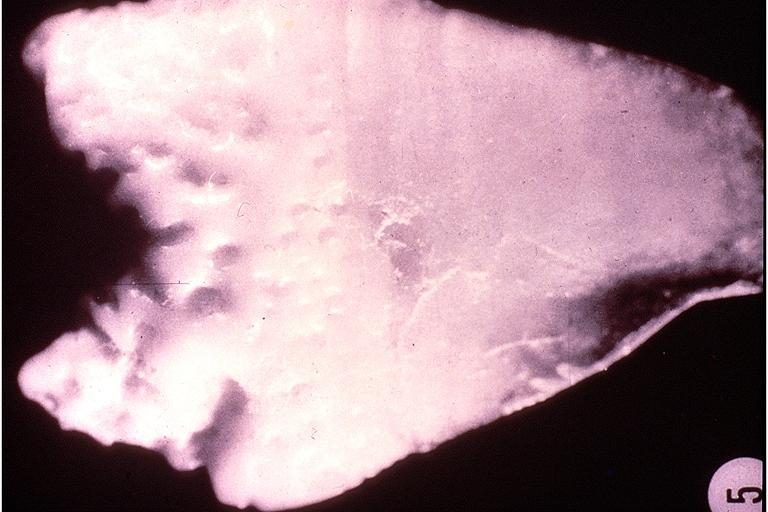what is present?
Answer the question using a single word or phrase. Oral 